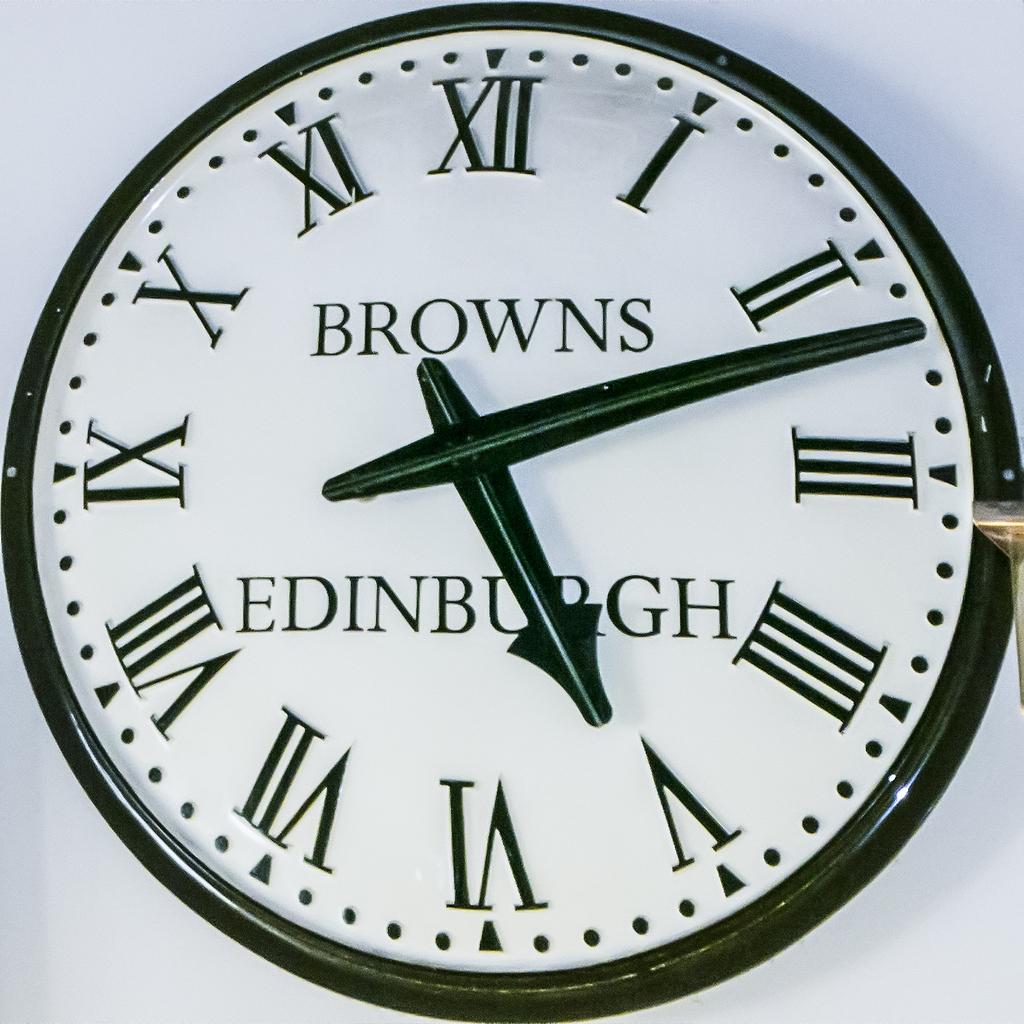Who built this clock?
Your response must be concise. Browns. Where was the clock built?
Provide a succinct answer. Edinburgh. 